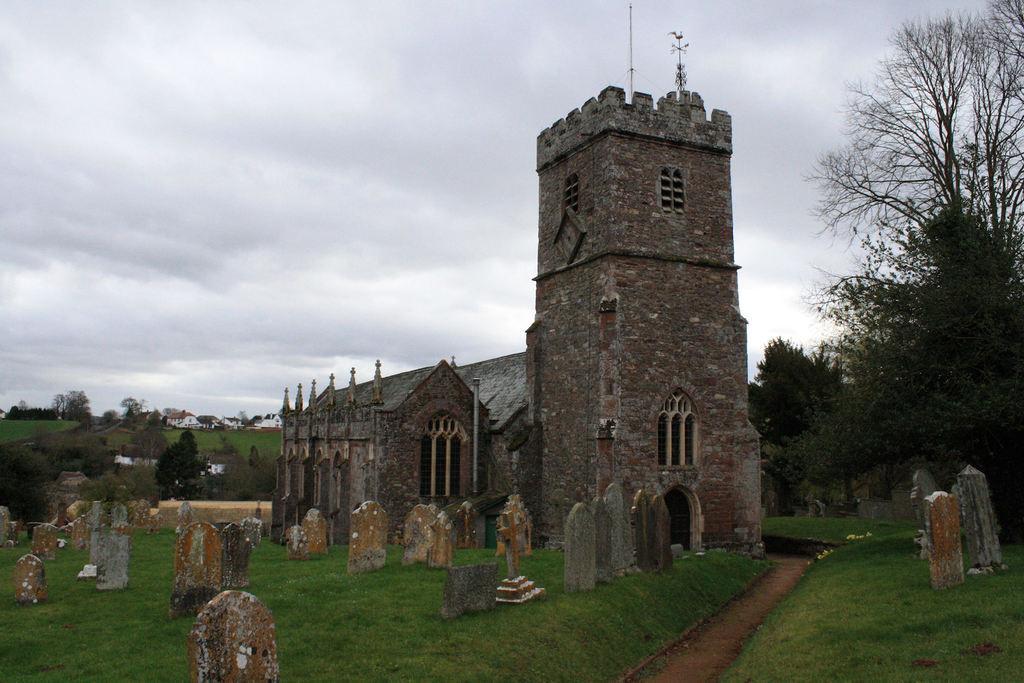How would you summarize this image in a sentence or two? In this image we can see a building with windows. We can also see a group of grave stones, grass, the pathway and a group of trees. On the backside we can see some buildings and the sky which looks cloudy. 